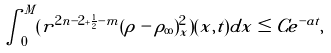Convert formula to latex. <formula><loc_0><loc_0><loc_500><loc_500>\int ^ { M } _ { 0 } ( r ^ { 2 n - 2 + { \frac { 1 } { 2 } - m } } ( \rho - \rho _ { \infty } ) _ { x } ^ { 2 } ) ( x , t ) d x \leq C e ^ { - a t } ,</formula> 